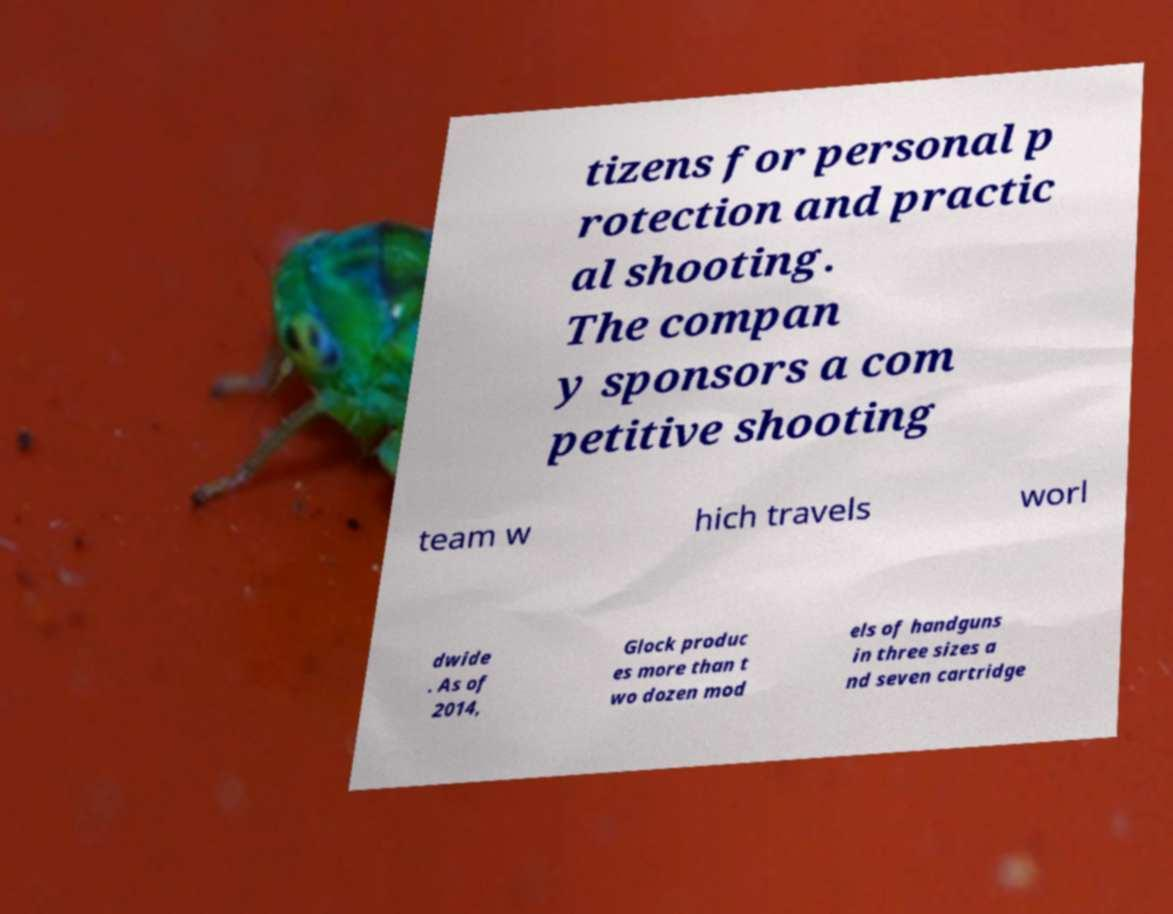For documentation purposes, I need the text within this image transcribed. Could you provide that? tizens for personal p rotection and practic al shooting. The compan y sponsors a com petitive shooting team w hich travels worl dwide . As of 2014, Glock produc es more than t wo dozen mod els of handguns in three sizes a nd seven cartridge 